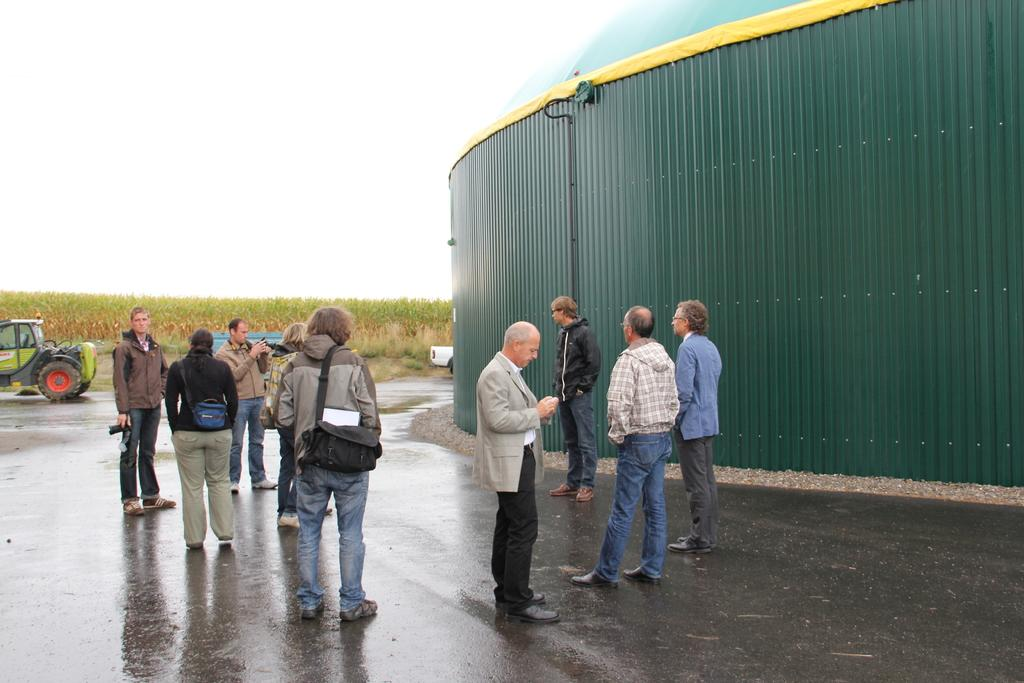How many people are present in the image? There are many people in the image. What are some people doing in the image? Some people are holding cameras. What else can be seen in the image besides people? There is a vehicle, trees in the background, and a building in the image. What type of glue is being used to attach the clouds to the sky in the image? There are no clouds present in the image, so there is no glue being used to attach them. 